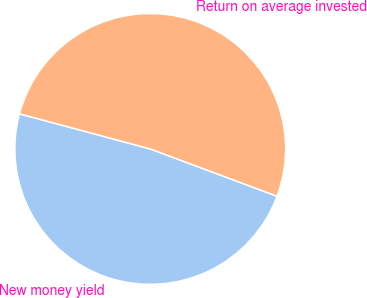Convert chart. <chart><loc_0><loc_0><loc_500><loc_500><pie_chart><fcel>New money yield<fcel>Return on average invested<nl><fcel>48.5%<fcel>51.5%<nl></chart> 